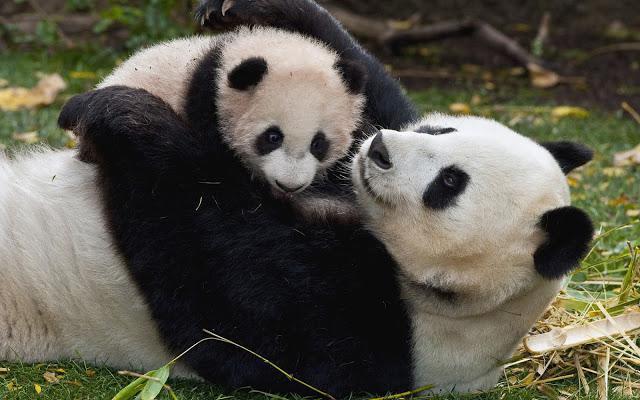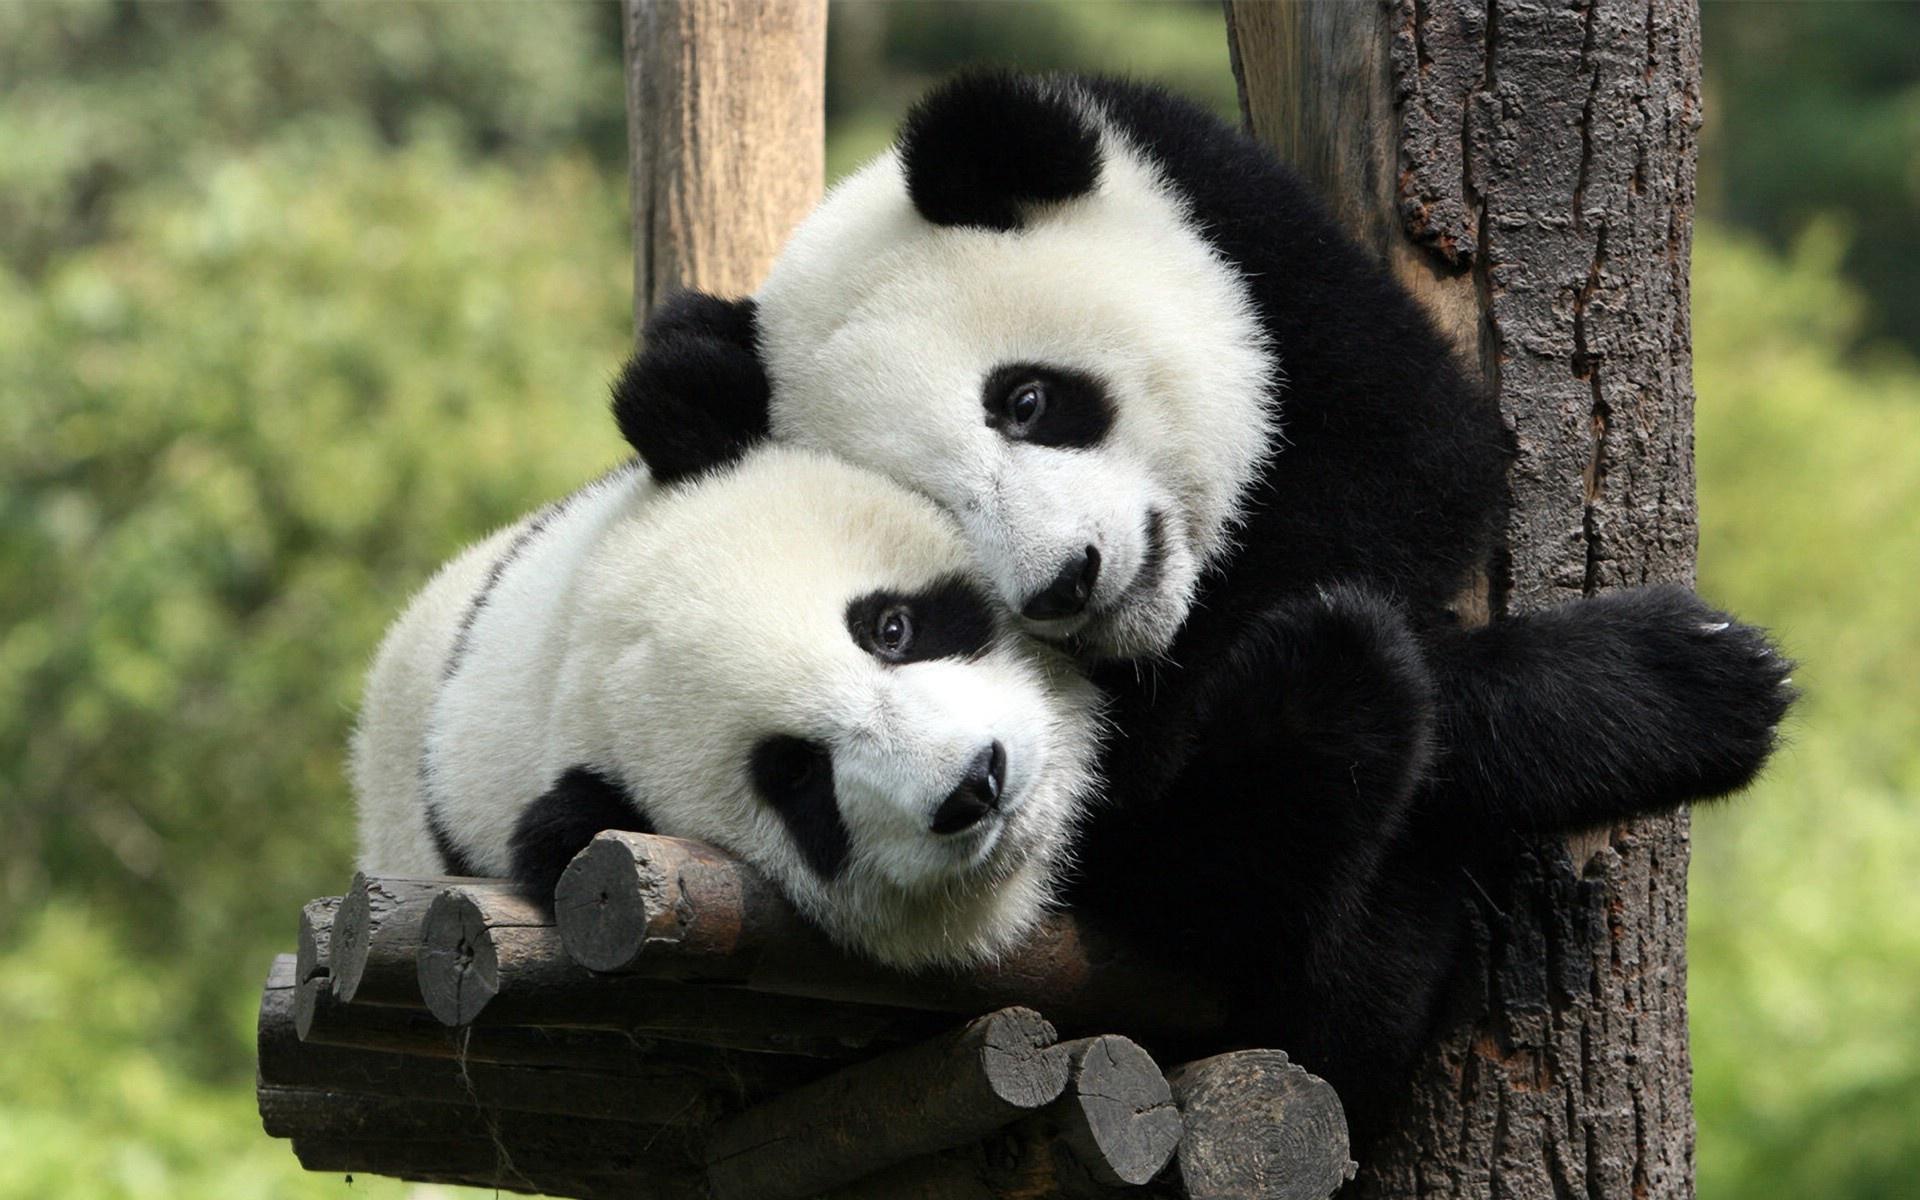The first image is the image on the left, the second image is the image on the right. Analyze the images presented: Is the assertion "A panda is playing with another panda in at least one of the images." valid? Answer yes or no. Yes. The first image is the image on the left, the second image is the image on the right. Assess this claim about the two images: "An image shows a panda on its back with a smaller panda on top of it.". Correct or not? Answer yes or no. Yes. 